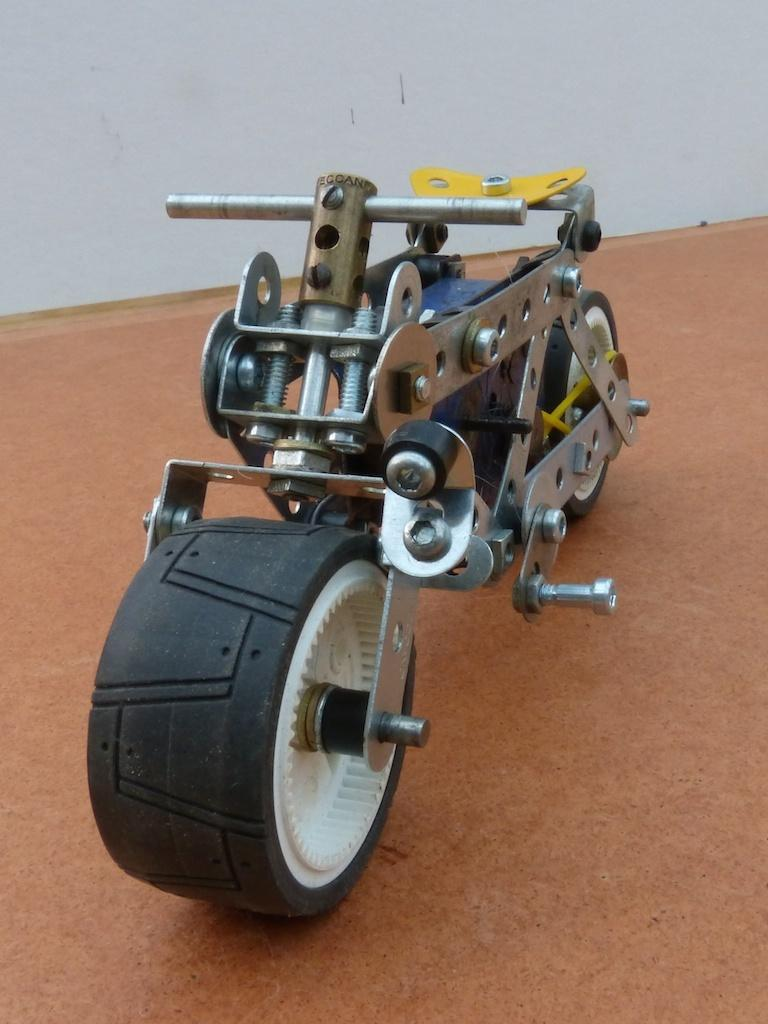What type of toy is in the image? There is a toy motorbike in the image. What is the toy motorbike placed on? The toy motorbike is on a wooden board. What can be seen in the background of the image? There is a wall in the background of the image. What type of fog can be seen in the image? There is no fog present in the image; it features a toy motorbike on a wooden board with a wall in the background. 